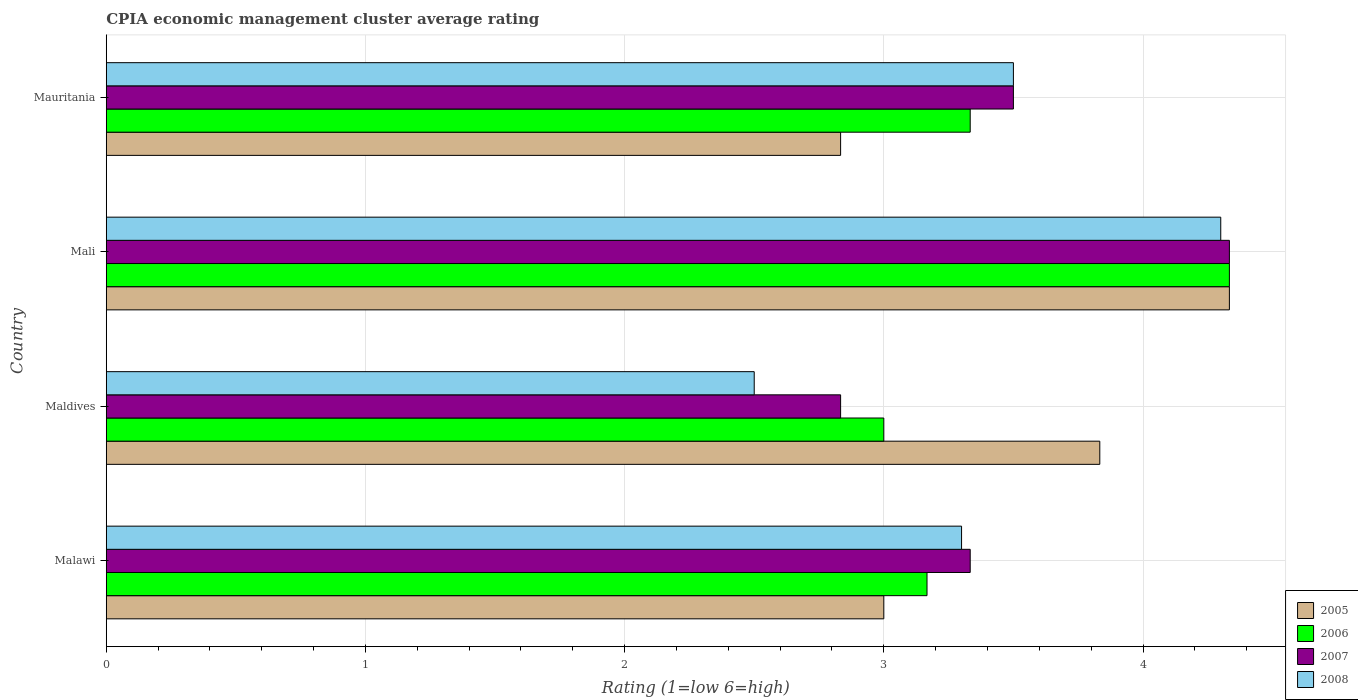How many groups of bars are there?
Ensure brevity in your answer.  4. Are the number of bars per tick equal to the number of legend labels?
Offer a terse response. Yes. What is the label of the 1st group of bars from the top?
Your answer should be compact. Mauritania. What is the CPIA rating in 2007 in Mali?
Ensure brevity in your answer.  4.33. Across all countries, what is the maximum CPIA rating in 2006?
Your answer should be compact. 4.33. Across all countries, what is the minimum CPIA rating in 2005?
Your answer should be very brief. 2.83. In which country was the CPIA rating in 2006 maximum?
Keep it short and to the point. Mali. In which country was the CPIA rating in 2006 minimum?
Provide a succinct answer. Maldives. What is the total CPIA rating in 2005 in the graph?
Make the answer very short. 14. What is the difference between the CPIA rating in 2008 in Maldives and that in Mauritania?
Give a very brief answer. -1. What is the difference between the CPIA rating in 2005 in Maldives and the CPIA rating in 2007 in Mauritania?
Ensure brevity in your answer.  0.33. What is the average CPIA rating in 2008 per country?
Make the answer very short. 3.4. What is the difference between the CPIA rating in 2008 and CPIA rating in 2005 in Mali?
Your answer should be very brief. -0.03. In how many countries, is the CPIA rating in 2006 greater than 0.4 ?
Offer a terse response. 4. What is the ratio of the CPIA rating in 2006 in Malawi to that in Maldives?
Your answer should be very brief. 1.06. Is the difference between the CPIA rating in 2008 in Mali and Mauritania greater than the difference between the CPIA rating in 2005 in Mali and Mauritania?
Provide a succinct answer. No. What is the difference between the highest and the second highest CPIA rating in 2008?
Your response must be concise. 0.8. What is the difference between the highest and the lowest CPIA rating in 2007?
Your response must be concise. 1.5. In how many countries, is the CPIA rating in 2008 greater than the average CPIA rating in 2008 taken over all countries?
Provide a short and direct response. 2. Is the sum of the CPIA rating in 2008 in Mali and Mauritania greater than the maximum CPIA rating in 2006 across all countries?
Your answer should be compact. Yes. Is it the case that in every country, the sum of the CPIA rating in 2007 and CPIA rating in 2006 is greater than the sum of CPIA rating in 2005 and CPIA rating in 2008?
Give a very brief answer. No. What does the 1st bar from the top in Mauritania represents?
Provide a short and direct response. 2008. What does the 1st bar from the bottom in Malawi represents?
Offer a very short reply. 2005. Is it the case that in every country, the sum of the CPIA rating in 2006 and CPIA rating in 2008 is greater than the CPIA rating in 2005?
Offer a terse response. Yes. How many bars are there?
Give a very brief answer. 16. How many countries are there in the graph?
Provide a succinct answer. 4. What is the difference between two consecutive major ticks on the X-axis?
Offer a very short reply. 1. Are the values on the major ticks of X-axis written in scientific E-notation?
Offer a very short reply. No. Does the graph contain any zero values?
Provide a short and direct response. No. Does the graph contain grids?
Your answer should be very brief. Yes. How many legend labels are there?
Keep it short and to the point. 4. What is the title of the graph?
Offer a very short reply. CPIA economic management cluster average rating. Does "1984" appear as one of the legend labels in the graph?
Your response must be concise. No. What is the label or title of the Y-axis?
Provide a succinct answer. Country. What is the Rating (1=low 6=high) in 2005 in Malawi?
Provide a succinct answer. 3. What is the Rating (1=low 6=high) in 2006 in Malawi?
Give a very brief answer. 3.17. What is the Rating (1=low 6=high) in 2007 in Malawi?
Give a very brief answer. 3.33. What is the Rating (1=low 6=high) in 2008 in Malawi?
Provide a short and direct response. 3.3. What is the Rating (1=low 6=high) in 2005 in Maldives?
Give a very brief answer. 3.83. What is the Rating (1=low 6=high) in 2007 in Maldives?
Your response must be concise. 2.83. What is the Rating (1=low 6=high) in 2005 in Mali?
Offer a very short reply. 4.33. What is the Rating (1=low 6=high) in 2006 in Mali?
Ensure brevity in your answer.  4.33. What is the Rating (1=low 6=high) of 2007 in Mali?
Provide a succinct answer. 4.33. What is the Rating (1=low 6=high) in 2008 in Mali?
Provide a succinct answer. 4.3. What is the Rating (1=low 6=high) of 2005 in Mauritania?
Your response must be concise. 2.83. What is the Rating (1=low 6=high) of 2006 in Mauritania?
Provide a short and direct response. 3.33. What is the Rating (1=low 6=high) of 2007 in Mauritania?
Make the answer very short. 3.5. Across all countries, what is the maximum Rating (1=low 6=high) in 2005?
Ensure brevity in your answer.  4.33. Across all countries, what is the maximum Rating (1=low 6=high) in 2006?
Provide a short and direct response. 4.33. Across all countries, what is the maximum Rating (1=low 6=high) in 2007?
Your response must be concise. 4.33. Across all countries, what is the maximum Rating (1=low 6=high) of 2008?
Your answer should be compact. 4.3. Across all countries, what is the minimum Rating (1=low 6=high) in 2005?
Ensure brevity in your answer.  2.83. Across all countries, what is the minimum Rating (1=low 6=high) of 2007?
Give a very brief answer. 2.83. What is the total Rating (1=low 6=high) of 2006 in the graph?
Keep it short and to the point. 13.83. What is the total Rating (1=low 6=high) in 2008 in the graph?
Keep it short and to the point. 13.6. What is the difference between the Rating (1=low 6=high) of 2007 in Malawi and that in Maldives?
Offer a very short reply. 0.5. What is the difference between the Rating (1=low 6=high) of 2005 in Malawi and that in Mali?
Offer a terse response. -1.33. What is the difference between the Rating (1=low 6=high) in 2006 in Malawi and that in Mali?
Provide a succinct answer. -1.17. What is the difference between the Rating (1=low 6=high) in 2007 in Malawi and that in Mali?
Your answer should be compact. -1. What is the difference between the Rating (1=low 6=high) in 2008 in Malawi and that in Mali?
Give a very brief answer. -1. What is the difference between the Rating (1=low 6=high) of 2005 in Malawi and that in Mauritania?
Offer a terse response. 0.17. What is the difference between the Rating (1=low 6=high) of 2007 in Malawi and that in Mauritania?
Provide a short and direct response. -0.17. What is the difference between the Rating (1=low 6=high) of 2006 in Maldives and that in Mali?
Give a very brief answer. -1.33. What is the difference between the Rating (1=low 6=high) in 2006 in Maldives and that in Mauritania?
Ensure brevity in your answer.  -0.33. What is the difference between the Rating (1=low 6=high) of 2007 in Maldives and that in Mauritania?
Keep it short and to the point. -0.67. What is the difference between the Rating (1=low 6=high) in 2007 in Mali and that in Mauritania?
Your response must be concise. 0.83. What is the difference between the Rating (1=low 6=high) in 2008 in Mali and that in Mauritania?
Provide a succinct answer. 0.8. What is the difference between the Rating (1=low 6=high) of 2005 in Malawi and the Rating (1=low 6=high) of 2006 in Maldives?
Your response must be concise. 0. What is the difference between the Rating (1=low 6=high) of 2006 in Malawi and the Rating (1=low 6=high) of 2007 in Maldives?
Ensure brevity in your answer.  0.33. What is the difference between the Rating (1=low 6=high) in 2006 in Malawi and the Rating (1=low 6=high) in 2008 in Maldives?
Provide a short and direct response. 0.67. What is the difference between the Rating (1=low 6=high) of 2005 in Malawi and the Rating (1=low 6=high) of 2006 in Mali?
Offer a terse response. -1.33. What is the difference between the Rating (1=low 6=high) of 2005 in Malawi and the Rating (1=low 6=high) of 2007 in Mali?
Provide a succinct answer. -1.33. What is the difference between the Rating (1=low 6=high) in 2006 in Malawi and the Rating (1=low 6=high) in 2007 in Mali?
Offer a terse response. -1.17. What is the difference between the Rating (1=low 6=high) of 2006 in Malawi and the Rating (1=low 6=high) of 2008 in Mali?
Your answer should be very brief. -1.13. What is the difference between the Rating (1=low 6=high) of 2007 in Malawi and the Rating (1=low 6=high) of 2008 in Mali?
Offer a very short reply. -0.97. What is the difference between the Rating (1=low 6=high) in 2005 in Malawi and the Rating (1=low 6=high) in 2006 in Mauritania?
Make the answer very short. -0.33. What is the difference between the Rating (1=low 6=high) of 2006 in Malawi and the Rating (1=low 6=high) of 2007 in Mauritania?
Provide a short and direct response. -0.33. What is the difference between the Rating (1=low 6=high) in 2005 in Maldives and the Rating (1=low 6=high) in 2006 in Mali?
Provide a short and direct response. -0.5. What is the difference between the Rating (1=low 6=high) of 2005 in Maldives and the Rating (1=low 6=high) of 2007 in Mali?
Give a very brief answer. -0.5. What is the difference between the Rating (1=low 6=high) of 2005 in Maldives and the Rating (1=low 6=high) of 2008 in Mali?
Give a very brief answer. -0.47. What is the difference between the Rating (1=low 6=high) in 2006 in Maldives and the Rating (1=low 6=high) in 2007 in Mali?
Keep it short and to the point. -1.33. What is the difference between the Rating (1=low 6=high) of 2007 in Maldives and the Rating (1=low 6=high) of 2008 in Mali?
Offer a very short reply. -1.47. What is the difference between the Rating (1=low 6=high) in 2005 in Maldives and the Rating (1=low 6=high) in 2006 in Mauritania?
Offer a very short reply. 0.5. What is the difference between the Rating (1=low 6=high) of 2005 in Mali and the Rating (1=low 6=high) of 2008 in Mauritania?
Provide a short and direct response. 0.83. What is the difference between the Rating (1=low 6=high) in 2006 in Mali and the Rating (1=low 6=high) in 2008 in Mauritania?
Provide a short and direct response. 0.83. What is the average Rating (1=low 6=high) of 2006 per country?
Give a very brief answer. 3.46. What is the difference between the Rating (1=low 6=high) in 2005 and Rating (1=low 6=high) in 2006 in Malawi?
Make the answer very short. -0.17. What is the difference between the Rating (1=low 6=high) of 2006 and Rating (1=low 6=high) of 2008 in Malawi?
Give a very brief answer. -0.13. What is the difference between the Rating (1=low 6=high) of 2007 and Rating (1=low 6=high) of 2008 in Malawi?
Make the answer very short. 0.03. What is the difference between the Rating (1=low 6=high) in 2005 and Rating (1=low 6=high) in 2006 in Mali?
Give a very brief answer. 0. What is the difference between the Rating (1=low 6=high) in 2005 and Rating (1=low 6=high) in 2007 in Mali?
Offer a terse response. 0. What is the difference between the Rating (1=low 6=high) in 2006 and Rating (1=low 6=high) in 2007 in Mali?
Your answer should be very brief. 0. What is the difference between the Rating (1=low 6=high) of 2006 and Rating (1=low 6=high) of 2008 in Mali?
Your response must be concise. 0.03. What is the difference between the Rating (1=low 6=high) in 2007 and Rating (1=low 6=high) in 2008 in Mali?
Make the answer very short. 0.03. What is the difference between the Rating (1=low 6=high) in 2005 and Rating (1=low 6=high) in 2006 in Mauritania?
Offer a terse response. -0.5. What is the difference between the Rating (1=low 6=high) in 2005 and Rating (1=low 6=high) in 2007 in Mauritania?
Offer a very short reply. -0.67. What is the difference between the Rating (1=low 6=high) in 2005 and Rating (1=low 6=high) in 2008 in Mauritania?
Offer a very short reply. -0.67. What is the difference between the Rating (1=low 6=high) in 2006 and Rating (1=low 6=high) in 2008 in Mauritania?
Provide a short and direct response. -0.17. What is the ratio of the Rating (1=low 6=high) of 2005 in Malawi to that in Maldives?
Keep it short and to the point. 0.78. What is the ratio of the Rating (1=low 6=high) in 2006 in Malawi to that in Maldives?
Your response must be concise. 1.06. What is the ratio of the Rating (1=low 6=high) of 2007 in Malawi to that in Maldives?
Your response must be concise. 1.18. What is the ratio of the Rating (1=low 6=high) in 2008 in Malawi to that in Maldives?
Your response must be concise. 1.32. What is the ratio of the Rating (1=low 6=high) of 2005 in Malawi to that in Mali?
Make the answer very short. 0.69. What is the ratio of the Rating (1=low 6=high) of 2006 in Malawi to that in Mali?
Keep it short and to the point. 0.73. What is the ratio of the Rating (1=low 6=high) in 2007 in Malawi to that in Mali?
Give a very brief answer. 0.77. What is the ratio of the Rating (1=low 6=high) in 2008 in Malawi to that in Mali?
Offer a very short reply. 0.77. What is the ratio of the Rating (1=low 6=high) in 2005 in Malawi to that in Mauritania?
Offer a terse response. 1.06. What is the ratio of the Rating (1=low 6=high) of 2008 in Malawi to that in Mauritania?
Ensure brevity in your answer.  0.94. What is the ratio of the Rating (1=low 6=high) of 2005 in Maldives to that in Mali?
Make the answer very short. 0.88. What is the ratio of the Rating (1=low 6=high) in 2006 in Maldives to that in Mali?
Offer a very short reply. 0.69. What is the ratio of the Rating (1=low 6=high) in 2007 in Maldives to that in Mali?
Give a very brief answer. 0.65. What is the ratio of the Rating (1=low 6=high) in 2008 in Maldives to that in Mali?
Keep it short and to the point. 0.58. What is the ratio of the Rating (1=low 6=high) in 2005 in Maldives to that in Mauritania?
Your answer should be very brief. 1.35. What is the ratio of the Rating (1=low 6=high) in 2007 in Maldives to that in Mauritania?
Your response must be concise. 0.81. What is the ratio of the Rating (1=low 6=high) in 2005 in Mali to that in Mauritania?
Ensure brevity in your answer.  1.53. What is the ratio of the Rating (1=low 6=high) in 2006 in Mali to that in Mauritania?
Provide a succinct answer. 1.3. What is the ratio of the Rating (1=low 6=high) of 2007 in Mali to that in Mauritania?
Provide a short and direct response. 1.24. What is the ratio of the Rating (1=low 6=high) of 2008 in Mali to that in Mauritania?
Provide a succinct answer. 1.23. What is the difference between the highest and the second highest Rating (1=low 6=high) of 2005?
Your answer should be very brief. 0.5. What is the difference between the highest and the second highest Rating (1=low 6=high) of 2006?
Give a very brief answer. 1. What is the difference between the highest and the second highest Rating (1=low 6=high) of 2008?
Make the answer very short. 0.8. What is the difference between the highest and the lowest Rating (1=low 6=high) in 2005?
Provide a short and direct response. 1.5. What is the difference between the highest and the lowest Rating (1=low 6=high) of 2006?
Your response must be concise. 1.33. What is the difference between the highest and the lowest Rating (1=low 6=high) of 2008?
Provide a short and direct response. 1.8. 